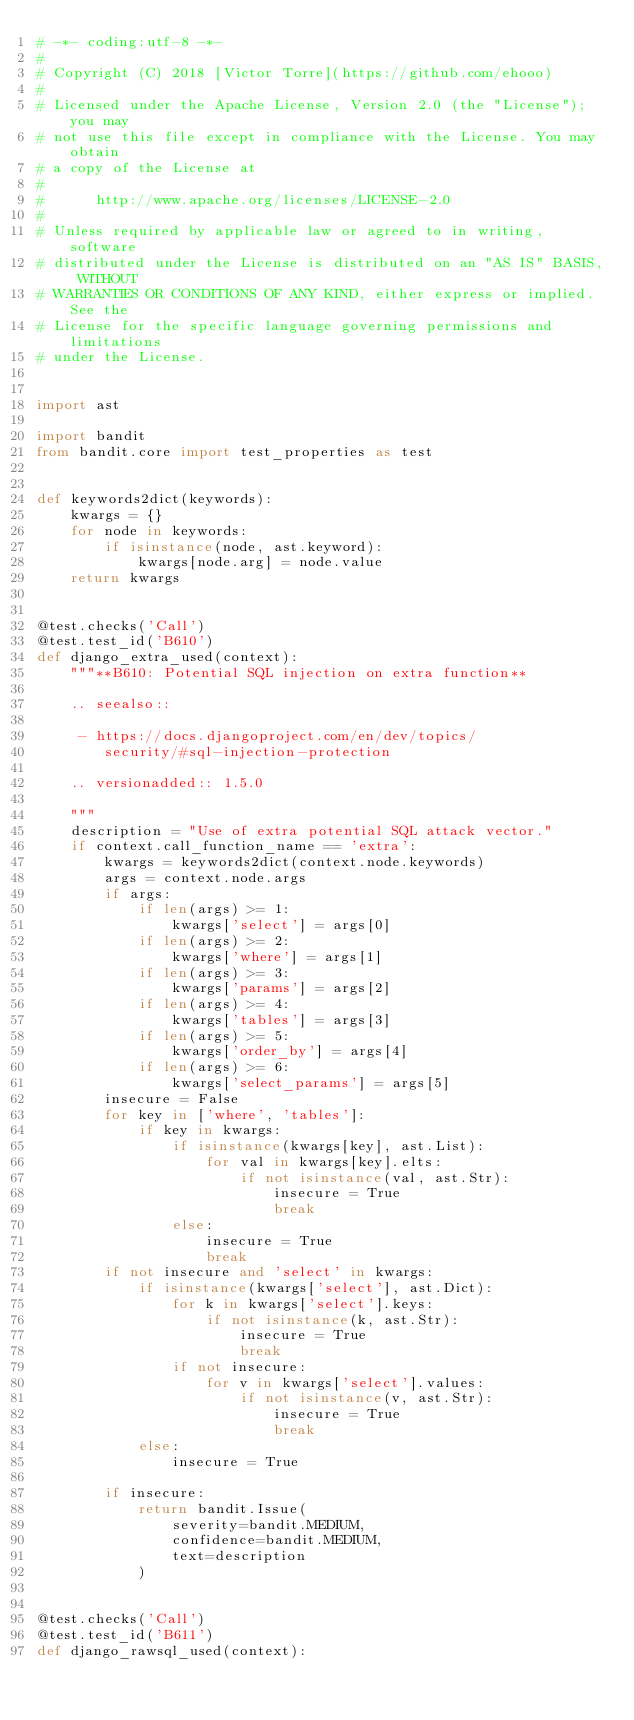<code> <loc_0><loc_0><loc_500><loc_500><_Python_># -*- coding:utf-8 -*-
#
# Copyright (C) 2018 [Victor Torre](https://github.com/ehooo)
#
# Licensed under the Apache License, Version 2.0 (the "License"); you may
# not use this file except in compliance with the License. You may obtain
# a copy of the License at
#
#      http://www.apache.org/licenses/LICENSE-2.0
#
# Unless required by applicable law or agreed to in writing, software
# distributed under the License is distributed on an "AS IS" BASIS, WITHOUT
# WARRANTIES OR CONDITIONS OF ANY KIND, either express or implied. See the
# License for the specific language governing permissions and limitations
# under the License.


import ast

import bandit
from bandit.core import test_properties as test


def keywords2dict(keywords):
    kwargs = {}
    for node in keywords:
        if isinstance(node, ast.keyword):
            kwargs[node.arg] = node.value
    return kwargs


@test.checks('Call')
@test.test_id('B610')
def django_extra_used(context):
    """**B610: Potential SQL injection on extra function**

    .. seealso::

     - https://docs.djangoproject.com/en/dev/topics/
        security/#sql-injection-protection

    .. versionadded:: 1.5.0

    """
    description = "Use of extra potential SQL attack vector."
    if context.call_function_name == 'extra':
        kwargs = keywords2dict(context.node.keywords)
        args = context.node.args
        if args:
            if len(args) >= 1:
                kwargs['select'] = args[0]
            if len(args) >= 2:
                kwargs['where'] = args[1]
            if len(args) >= 3:
                kwargs['params'] = args[2]
            if len(args) >= 4:
                kwargs['tables'] = args[3]
            if len(args) >= 5:
                kwargs['order_by'] = args[4]
            if len(args) >= 6:
                kwargs['select_params'] = args[5]
        insecure = False
        for key in ['where', 'tables']:
            if key in kwargs:
                if isinstance(kwargs[key], ast.List):
                    for val in kwargs[key].elts:
                        if not isinstance(val, ast.Str):
                            insecure = True
                            break
                else:
                    insecure = True
                    break
        if not insecure and 'select' in kwargs:
            if isinstance(kwargs['select'], ast.Dict):
                for k in kwargs['select'].keys:
                    if not isinstance(k, ast.Str):
                        insecure = True
                        break
                if not insecure:
                    for v in kwargs['select'].values:
                        if not isinstance(v, ast.Str):
                            insecure = True
                            break
            else:
                insecure = True

        if insecure:
            return bandit.Issue(
                severity=bandit.MEDIUM,
                confidence=bandit.MEDIUM,
                text=description
            )


@test.checks('Call')
@test.test_id('B611')
def django_rawsql_used(context):</code> 